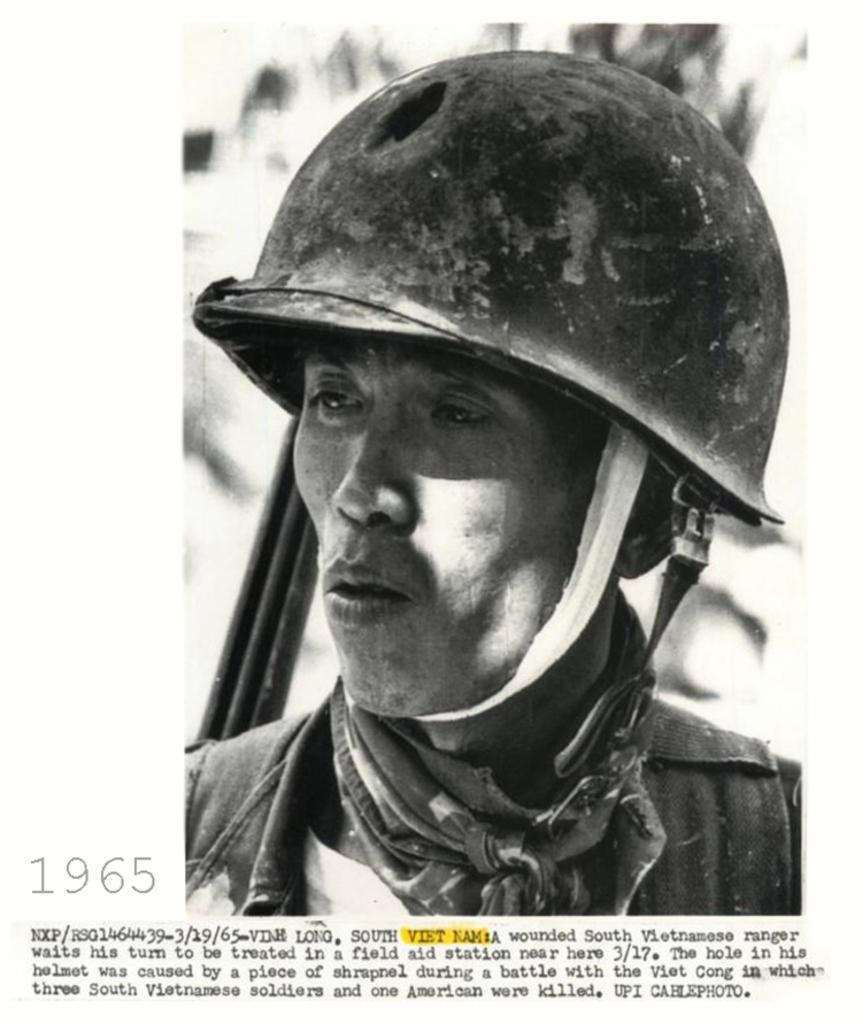What is the main subject of the image? There is a picture of a man in the image. What is the man wearing on his head? The man is wearing a helmet. What type of accessory is around the man's neck? There is a cloth around the man's neck. What can be found at the bottom of the image? There is text written at the bottom of the image. What color is the crayon that the man's son is holding in the image? There is no mention of a son or a crayon in the image; it only features a picture of a man with a helmet and a cloth around his neck, along with text at the bottom. 